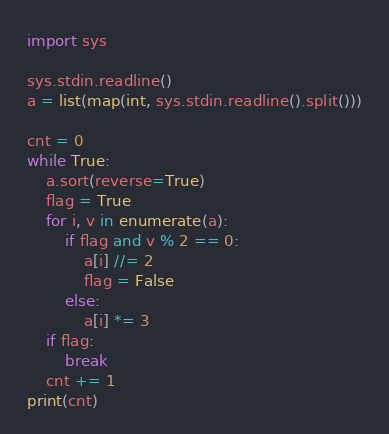Convert code to text. <code><loc_0><loc_0><loc_500><loc_500><_Python_>import sys

sys.stdin.readline()
a = list(map(int, sys.stdin.readline().split()))

cnt = 0
while True:
    a.sort(reverse=True)
    flag = True
    for i, v in enumerate(a):
        if flag and v % 2 == 0:
            a[i] //= 2
            flag = False
        else:
            a[i] *= 3
    if flag:
        break
    cnt += 1
print(cnt)</code> 